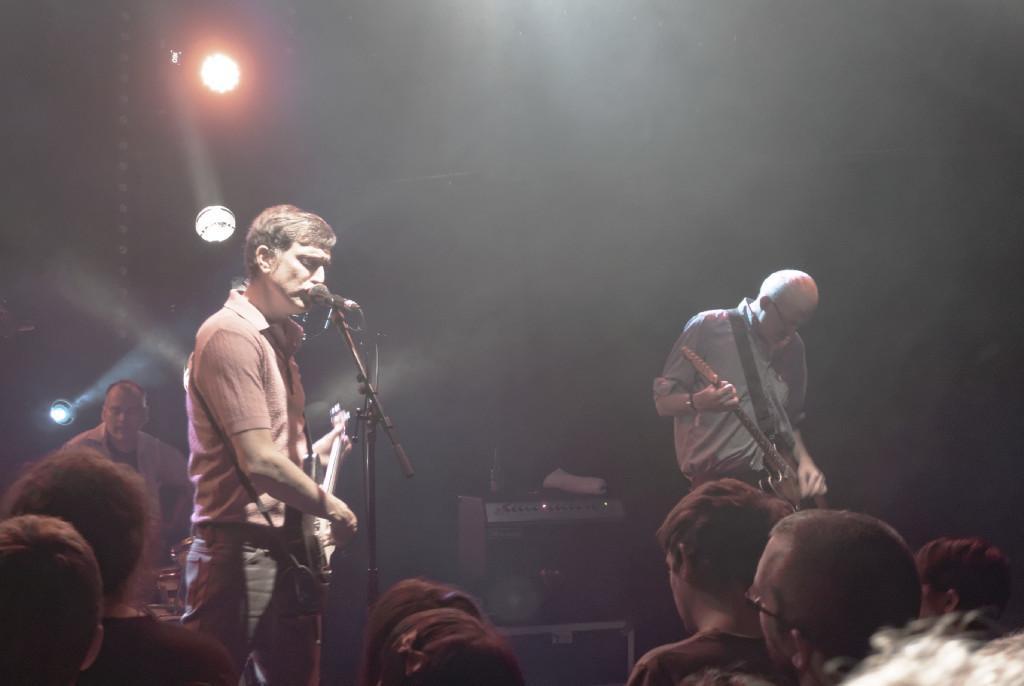How would you summarize this image in a sentence or two? These are lights. Background is blurry. We can see persons standing and playing guitar. Here in front of the picture we can see audience. 